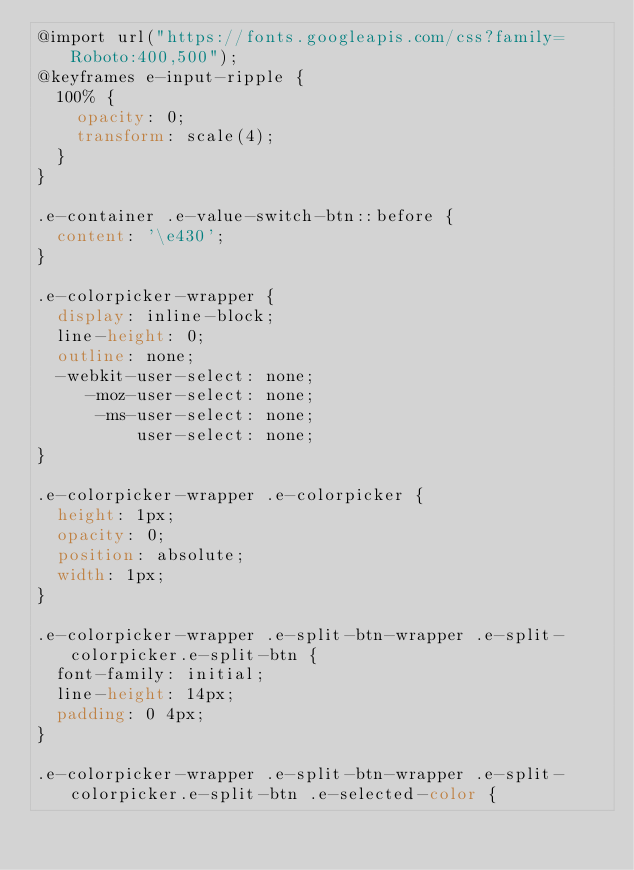<code> <loc_0><loc_0><loc_500><loc_500><_CSS_>@import url("https://fonts.googleapis.com/css?family=Roboto:400,500");
@keyframes e-input-ripple {
  100% {
    opacity: 0;
    transform: scale(4);
  }
}

.e-container .e-value-switch-btn::before {
  content: '\e430';
}

.e-colorpicker-wrapper {
  display: inline-block;
  line-height: 0;
  outline: none;
  -webkit-user-select: none;
     -moz-user-select: none;
      -ms-user-select: none;
          user-select: none;
}

.e-colorpicker-wrapper .e-colorpicker {
  height: 1px;
  opacity: 0;
  position: absolute;
  width: 1px;
}

.e-colorpicker-wrapper .e-split-btn-wrapper .e-split-colorpicker.e-split-btn {
  font-family: initial;
  line-height: 14px;
  padding: 0 4px;
}

.e-colorpicker-wrapper .e-split-btn-wrapper .e-split-colorpicker.e-split-btn .e-selected-color {</code> 